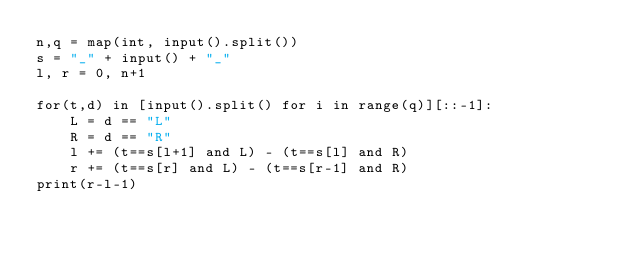Convert code to text. <code><loc_0><loc_0><loc_500><loc_500><_Python_>n,q = map(int, input().split())
s = "_" + input() + "_"
l, r = 0, n+1

for(t,d) in [input().split() for i in range(q)][::-1]:
    L = d == "L"
    R = d == "R"
    l += (t==s[l+1] and L) - (t==s[l] and R)
    r += (t==s[r] and L) - (t==s[r-1] and R)
print(r-l-1)
</code> 